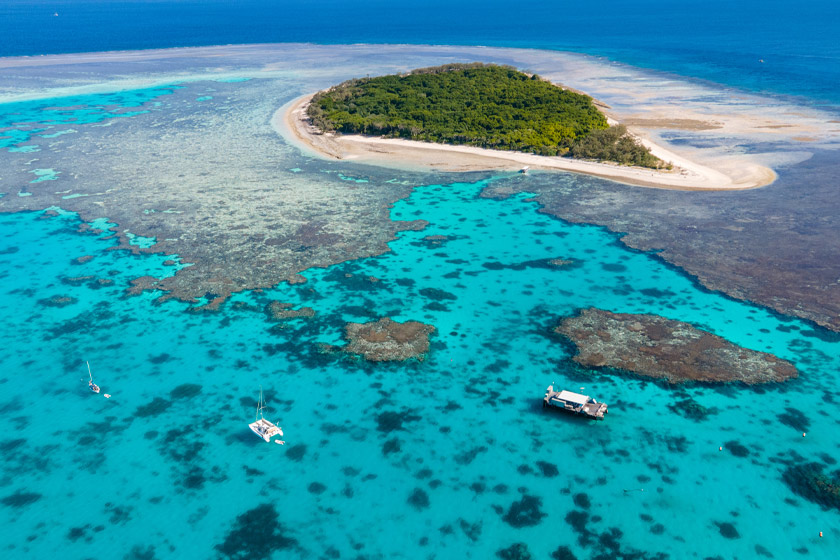Can you describe the main features of this image for me? This striking aerial image showcases the Great Barrier Reef, the world's largest coral reef system, located off the coast of Queensland, Australia. It features vivid turquoise waters interwoven with coral formations visible beneath the clear sea surface, emphasizing the intricate natural patterns and biodiversity. The image includes a small, lush green island that provides a stark contrast to the beige sandbanks and the deep blue ocean depths. Several boats, hinting at human interaction and exploration activities, are spread across the water, possibly filled with tourists eager to witness the reef’s natural beauty firsthand. This scene not only captures the reef's aesthetic appeal but also hints at the ecological significance and conservation challenges it faces. 